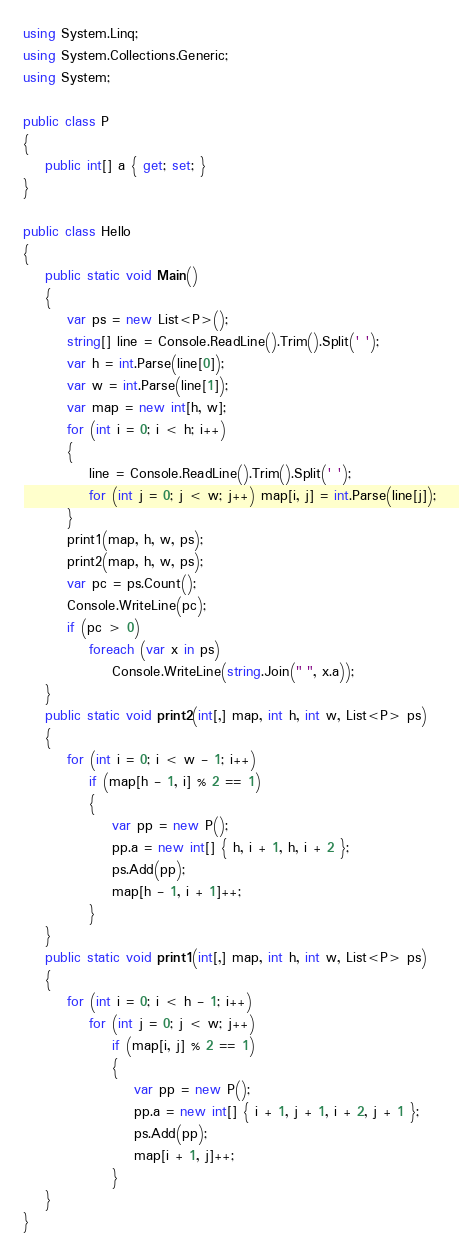Convert code to text. <code><loc_0><loc_0><loc_500><loc_500><_C#_>using System.Linq;
using System.Collections.Generic;
using System;

public class P
{
    public int[] a { get; set; }
}

public class Hello
{
    public static void Main()
    {
        var ps = new List<P>();
        string[] line = Console.ReadLine().Trim().Split(' ');
        var h = int.Parse(line[0]);
        var w = int.Parse(line[1]);
        var map = new int[h, w];
        for (int i = 0; i < h; i++)
        {
            line = Console.ReadLine().Trim().Split(' ');
            for (int j = 0; j < w; j++) map[i, j] = int.Parse(line[j]);
        }
        print1(map, h, w, ps);
        print2(map, h, w, ps);
        var pc = ps.Count();
        Console.WriteLine(pc);
        if (pc > 0)
            foreach (var x in ps)
                Console.WriteLine(string.Join(" ", x.a));
    }
    public static void print2(int[,] map, int h, int w, List<P> ps)
    {
        for (int i = 0; i < w - 1; i++)
            if (map[h - 1, i] % 2 == 1)
            {
                var pp = new P();
                pp.a = new int[] { h, i + 1, h, i + 2 };
                ps.Add(pp);
                map[h - 1, i + 1]++;
            }
    }
    public static void print1(int[,] map, int h, int w, List<P> ps)
    {
        for (int i = 0; i < h - 1; i++)
            for (int j = 0; j < w; j++)
                if (map[i, j] % 2 == 1)
                {
                    var pp = new P();
                    pp.a = new int[] { i + 1, j + 1, i + 2, j + 1 };
                    ps.Add(pp);
                    map[i + 1, j]++;
                }
    }
}
</code> 